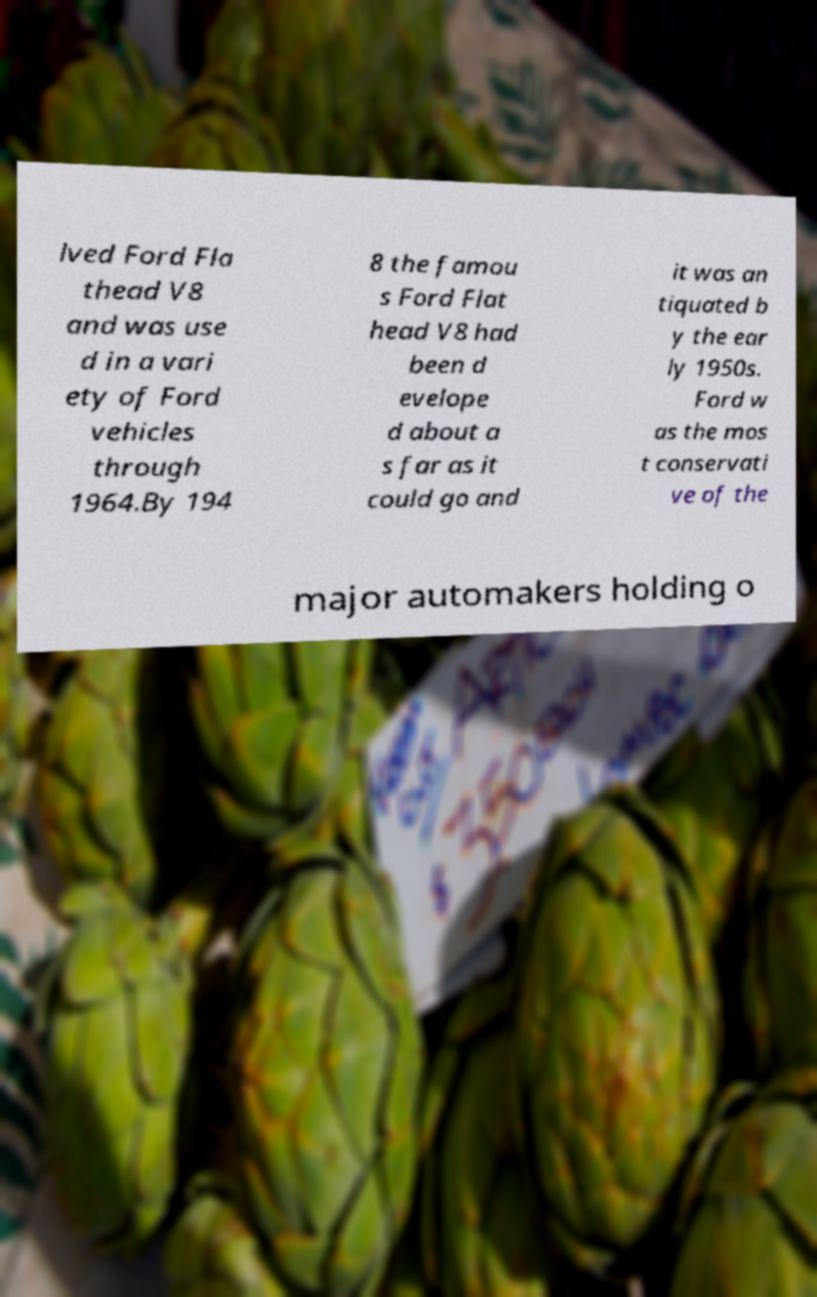Please read and relay the text visible in this image. What does it say? lved Ford Fla thead V8 and was use d in a vari ety of Ford vehicles through 1964.By 194 8 the famou s Ford Flat head V8 had been d evelope d about a s far as it could go and it was an tiquated b y the ear ly 1950s. Ford w as the mos t conservati ve of the major automakers holding o 